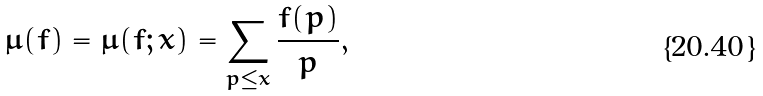<formula> <loc_0><loc_0><loc_500><loc_500>\mu ( f ) = \mu ( f ; x ) = \sum _ { p \leq x } \frac { f ( p ) } { p } ,</formula> 